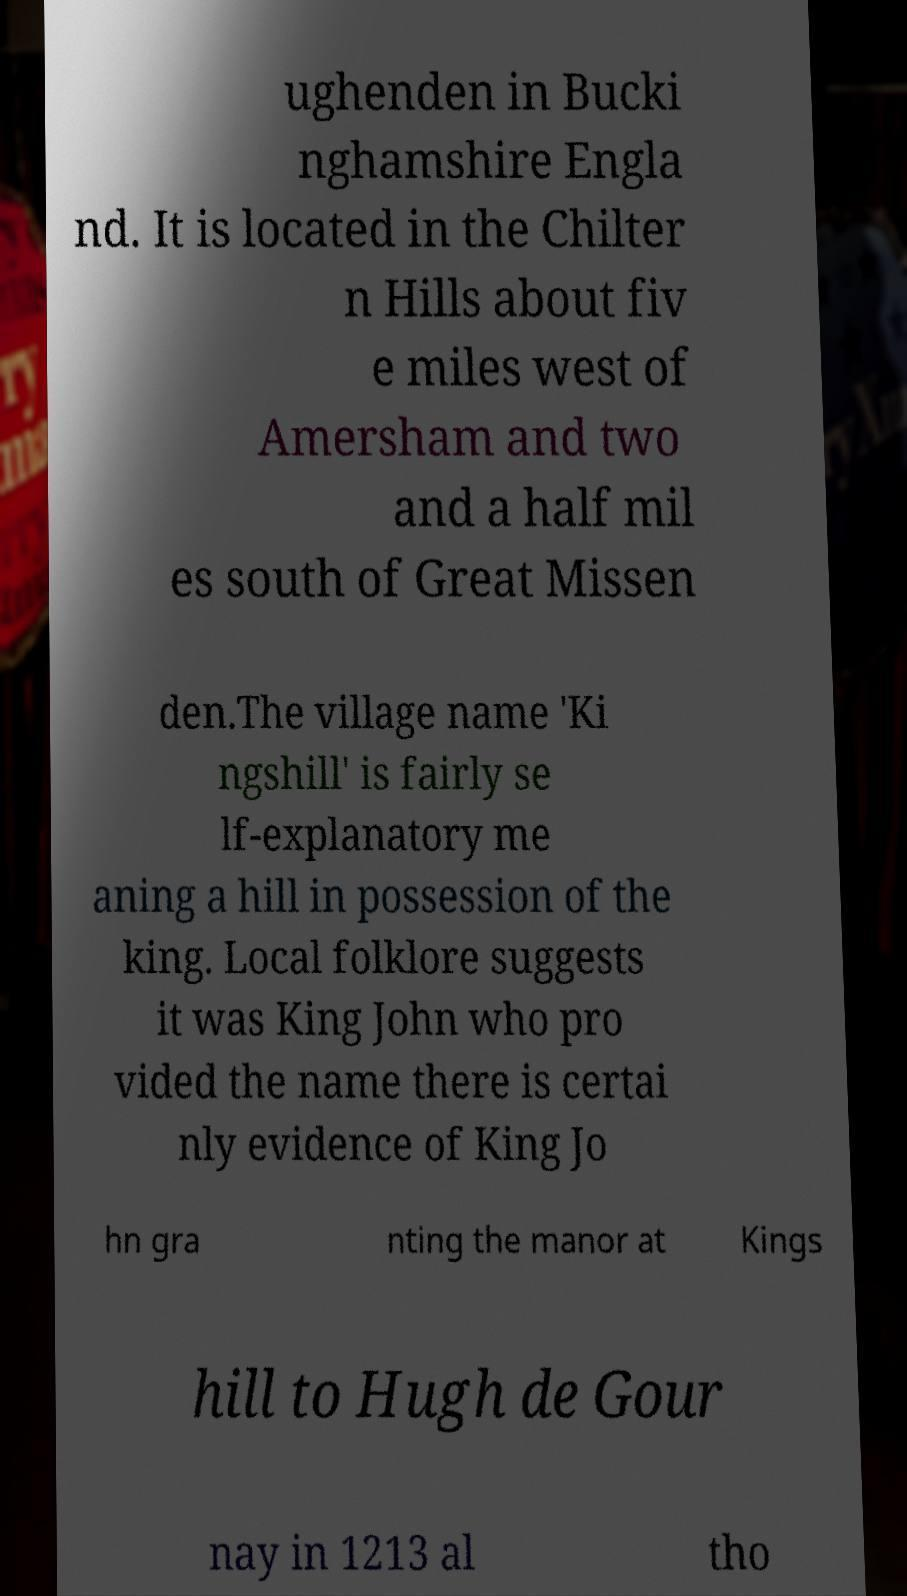Please identify and transcribe the text found in this image. ughenden in Bucki nghamshire Engla nd. It is located in the Chilter n Hills about fiv e miles west of Amersham and two and a half mil es south of Great Missen den.The village name 'Ki ngshill' is fairly se lf-explanatory me aning a hill in possession of the king. Local folklore suggests it was King John who pro vided the name there is certai nly evidence of King Jo hn gra nting the manor at Kings hill to Hugh de Gour nay in 1213 al tho 